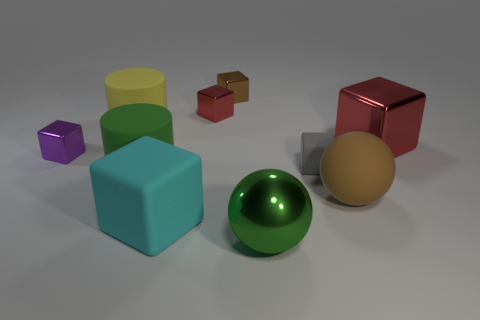Subtract all red blocks. How many were subtracted if there are1red blocks left? 1 Subtract all cyan cubes. How many cubes are left? 5 Subtract all small gray blocks. How many blocks are left? 5 Subtract all red cubes. Subtract all brown balls. How many cubes are left? 4 Subtract all blocks. How many objects are left? 4 Add 2 shiny cubes. How many shiny cubes exist? 6 Subtract 0 cyan spheres. How many objects are left? 10 Subtract all large cylinders. Subtract all small brown shiny blocks. How many objects are left? 7 Add 9 large red blocks. How many large red blocks are left? 10 